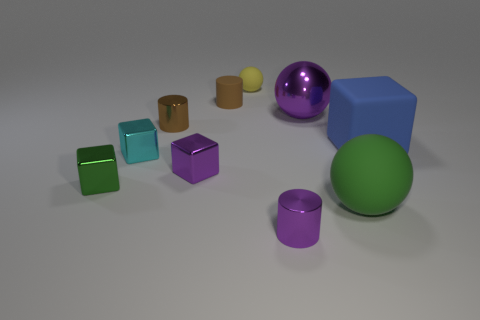There is a tiny cylinder in front of the brown shiny thing; is it the same color as the large metal object?
Provide a short and direct response. Yes. Is there any other thing that has the same color as the big rubber sphere?
Offer a very short reply. Yes. What number of other things are there of the same material as the cyan object
Provide a succinct answer. 5. Are the cylinder that is in front of the cyan block and the big sphere behind the blue rubber cube made of the same material?
Give a very brief answer. Yes. How many blocks are both right of the purple ball and on the left side of the cyan metal thing?
Your response must be concise. 0. Is there another rubber thing of the same shape as the yellow rubber object?
Ensure brevity in your answer.  Yes. What shape is the green shiny thing that is the same size as the cyan object?
Make the answer very short. Cube. Is the number of blue matte blocks left of the yellow object the same as the number of small brown metallic objects in front of the purple shiny block?
Make the answer very short. Yes. How big is the cylinder that is in front of the green object that is left of the small purple metal block?
Ensure brevity in your answer.  Small. Is there a purple metallic sphere that has the same size as the cyan metallic block?
Provide a short and direct response. No. 